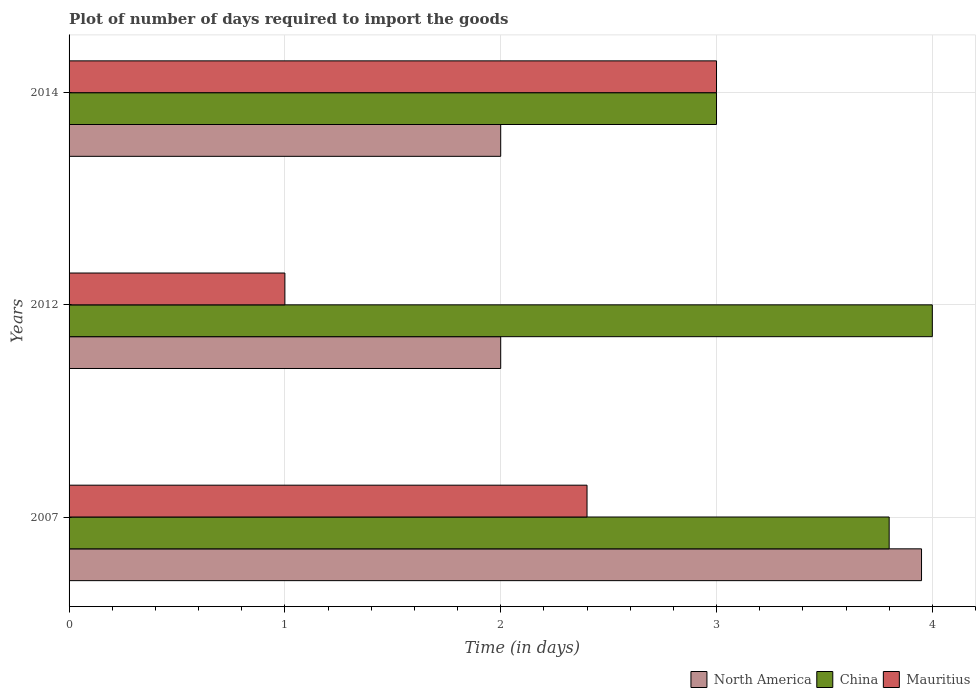How many different coloured bars are there?
Ensure brevity in your answer.  3. How many groups of bars are there?
Your answer should be compact. 3. Are the number of bars on each tick of the Y-axis equal?
Your answer should be very brief. Yes. How many bars are there on the 2nd tick from the bottom?
Offer a very short reply. 3. What is the label of the 2nd group of bars from the top?
Provide a short and direct response. 2012. What is the time required to import goods in China in 2014?
Give a very brief answer. 3. In which year was the time required to import goods in Mauritius maximum?
Offer a very short reply. 2014. What is the total time required to import goods in North America in the graph?
Keep it short and to the point. 7.95. What is the difference between the time required to import goods in Mauritius in 2007 and that in 2014?
Ensure brevity in your answer.  -0.6. What is the difference between the time required to import goods in Mauritius in 2014 and the time required to import goods in China in 2012?
Keep it short and to the point. -1. What is the average time required to import goods in China per year?
Give a very brief answer. 3.6. What is the ratio of the time required to import goods in China in 2007 to that in 2014?
Ensure brevity in your answer.  1.27. Is the time required to import goods in China in 2007 less than that in 2012?
Offer a terse response. Yes. Is the difference between the time required to import goods in North America in 2012 and 2014 greater than the difference between the time required to import goods in Mauritius in 2012 and 2014?
Make the answer very short. Yes. What is the difference between the highest and the second highest time required to import goods in China?
Provide a short and direct response. 0.2. What is the difference between the highest and the lowest time required to import goods in North America?
Give a very brief answer. 1.95. Is the sum of the time required to import goods in North America in 2012 and 2014 greater than the maximum time required to import goods in China across all years?
Your answer should be compact. No. What does the 3rd bar from the bottom in 2014 represents?
Keep it short and to the point. Mauritius. How many bars are there?
Keep it short and to the point. 9. What is the difference between two consecutive major ticks on the X-axis?
Provide a short and direct response. 1. Does the graph contain any zero values?
Your answer should be compact. No. Where does the legend appear in the graph?
Ensure brevity in your answer.  Bottom right. How many legend labels are there?
Your answer should be compact. 3. What is the title of the graph?
Provide a succinct answer. Plot of number of days required to import the goods. Does "South Asia" appear as one of the legend labels in the graph?
Offer a very short reply. No. What is the label or title of the X-axis?
Ensure brevity in your answer.  Time (in days). What is the Time (in days) in North America in 2007?
Keep it short and to the point. 3.95. What is the Time (in days) of China in 2012?
Give a very brief answer. 4. What is the Time (in days) in Mauritius in 2012?
Keep it short and to the point. 1. What is the Time (in days) in North America in 2014?
Offer a very short reply. 2. What is the Time (in days) in China in 2014?
Offer a very short reply. 3. What is the Time (in days) in Mauritius in 2014?
Keep it short and to the point. 3. Across all years, what is the maximum Time (in days) in North America?
Offer a terse response. 3.95. Across all years, what is the minimum Time (in days) in North America?
Your response must be concise. 2. What is the total Time (in days) of North America in the graph?
Offer a terse response. 7.95. What is the total Time (in days) of Mauritius in the graph?
Your answer should be compact. 6.4. What is the difference between the Time (in days) in North America in 2007 and that in 2012?
Ensure brevity in your answer.  1.95. What is the difference between the Time (in days) of China in 2007 and that in 2012?
Give a very brief answer. -0.2. What is the difference between the Time (in days) in North America in 2007 and that in 2014?
Provide a succinct answer. 1.95. What is the difference between the Time (in days) of China in 2007 and that in 2014?
Offer a very short reply. 0.8. What is the difference between the Time (in days) of Mauritius in 2007 and that in 2014?
Provide a succinct answer. -0.6. What is the difference between the Time (in days) in North America in 2012 and that in 2014?
Offer a very short reply. 0. What is the difference between the Time (in days) of Mauritius in 2012 and that in 2014?
Provide a short and direct response. -2. What is the difference between the Time (in days) of North America in 2007 and the Time (in days) of Mauritius in 2012?
Give a very brief answer. 2.95. What is the difference between the Time (in days) of China in 2007 and the Time (in days) of Mauritius in 2012?
Offer a terse response. 2.8. What is the difference between the Time (in days) in North America in 2012 and the Time (in days) in China in 2014?
Offer a terse response. -1. What is the difference between the Time (in days) of North America in 2012 and the Time (in days) of Mauritius in 2014?
Provide a short and direct response. -1. What is the difference between the Time (in days) in China in 2012 and the Time (in days) in Mauritius in 2014?
Offer a terse response. 1. What is the average Time (in days) of North America per year?
Provide a short and direct response. 2.65. What is the average Time (in days) in China per year?
Your response must be concise. 3.6. What is the average Time (in days) of Mauritius per year?
Provide a short and direct response. 2.13. In the year 2007, what is the difference between the Time (in days) of North America and Time (in days) of Mauritius?
Make the answer very short. 1.55. In the year 2007, what is the difference between the Time (in days) in China and Time (in days) in Mauritius?
Keep it short and to the point. 1.4. In the year 2012, what is the difference between the Time (in days) in North America and Time (in days) in China?
Provide a short and direct response. -2. In the year 2012, what is the difference between the Time (in days) of North America and Time (in days) of Mauritius?
Provide a short and direct response. 1. In the year 2014, what is the difference between the Time (in days) of North America and Time (in days) of China?
Make the answer very short. -1. In the year 2014, what is the difference between the Time (in days) of China and Time (in days) of Mauritius?
Your answer should be very brief. 0. What is the ratio of the Time (in days) in North America in 2007 to that in 2012?
Provide a succinct answer. 1.98. What is the ratio of the Time (in days) of China in 2007 to that in 2012?
Give a very brief answer. 0.95. What is the ratio of the Time (in days) of North America in 2007 to that in 2014?
Your answer should be very brief. 1.98. What is the ratio of the Time (in days) of China in 2007 to that in 2014?
Give a very brief answer. 1.27. What is the ratio of the Time (in days) of Mauritius in 2007 to that in 2014?
Your answer should be very brief. 0.8. What is the ratio of the Time (in days) in China in 2012 to that in 2014?
Provide a short and direct response. 1.33. What is the difference between the highest and the second highest Time (in days) of North America?
Give a very brief answer. 1.95. What is the difference between the highest and the lowest Time (in days) of North America?
Provide a succinct answer. 1.95. What is the difference between the highest and the lowest Time (in days) in China?
Your response must be concise. 1. What is the difference between the highest and the lowest Time (in days) of Mauritius?
Keep it short and to the point. 2. 